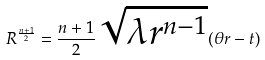Convert formula to latex. <formula><loc_0><loc_0><loc_500><loc_500>R ^ { \frac { n + 1 } { 2 } } = \frac { n + 1 } { 2 } \sqrt { \lambda r ^ { n - 1 } } ( \theta r - t )</formula> 